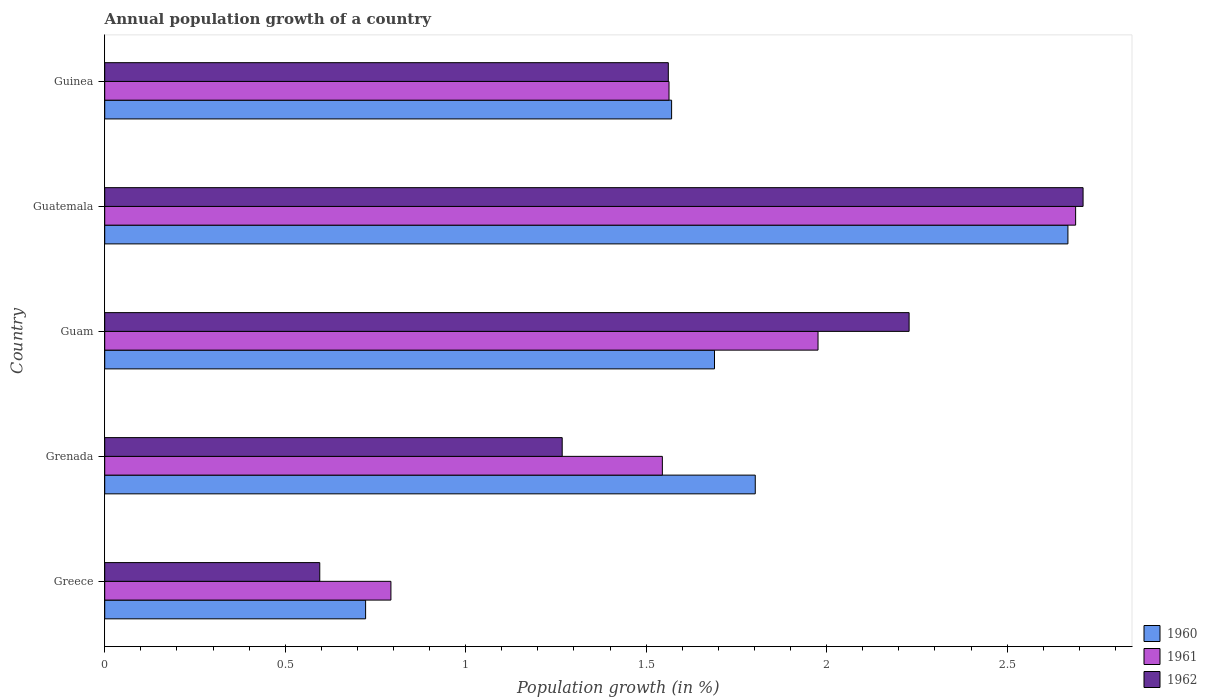Are the number of bars per tick equal to the number of legend labels?
Give a very brief answer. Yes. How many bars are there on the 1st tick from the top?
Provide a short and direct response. 3. How many bars are there on the 3rd tick from the bottom?
Offer a very short reply. 3. What is the label of the 1st group of bars from the top?
Offer a very short reply. Guinea. What is the annual population growth in 1960 in Guatemala?
Offer a very short reply. 2.67. Across all countries, what is the maximum annual population growth in 1962?
Ensure brevity in your answer.  2.71. Across all countries, what is the minimum annual population growth in 1960?
Your answer should be very brief. 0.72. In which country was the annual population growth in 1961 maximum?
Your answer should be compact. Guatemala. In which country was the annual population growth in 1960 minimum?
Give a very brief answer. Greece. What is the total annual population growth in 1961 in the graph?
Offer a terse response. 8.57. What is the difference between the annual population growth in 1961 in Guatemala and that in Guinea?
Provide a short and direct response. 1.13. What is the difference between the annual population growth in 1961 in Guatemala and the annual population growth in 1962 in Greece?
Ensure brevity in your answer.  2.09. What is the average annual population growth in 1961 per country?
Offer a terse response. 1.71. What is the difference between the annual population growth in 1960 and annual population growth in 1962 in Grenada?
Ensure brevity in your answer.  0.53. In how many countries, is the annual population growth in 1961 greater than 1.6 %?
Make the answer very short. 2. What is the ratio of the annual population growth in 1962 in Guam to that in Guatemala?
Offer a very short reply. 0.82. Is the annual population growth in 1962 in Greece less than that in Guatemala?
Give a very brief answer. Yes. Is the difference between the annual population growth in 1960 in Greece and Grenada greater than the difference between the annual population growth in 1962 in Greece and Grenada?
Make the answer very short. No. What is the difference between the highest and the second highest annual population growth in 1961?
Keep it short and to the point. 0.71. What is the difference between the highest and the lowest annual population growth in 1961?
Give a very brief answer. 1.9. What does the 3rd bar from the top in Greece represents?
Your answer should be compact. 1960. What does the 2nd bar from the bottom in Greece represents?
Provide a succinct answer. 1961. Is it the case that in every country, the sum of the annual population growth in 1962 and annual population growth in 1960 is greater than the annual population growth in 1961?
Keep it short and to the point. Yes. How many bars are there?
Give a very brief answer. 15. Are all the bars in the graph horizontal?
Keep it short and to the point. Yes. Does the graph contain grids?
Keep it short and to the point. No. How many legend labels are there?
Your answer should be compact. 3. How are the legend labels stacked?
Ensure brevity in your answer.  Vertical. What is the title of the graph?
Offer a very short reply. Annual population growth of a country. What is the label or title of the X-axis?
Your answer should be compact. Population growth (in %). What is the label or title of the Y-axis?
Offer a very short reply. Country. What is the Population growth (in %) in 1960 in Greece?
Your response must be concise. 0.72. What is the Population growth (in %) in 1961 in Greece?
Ensure brevity in your answer.  0.79. What is the Population growth (in %) of 1962 in Greece?
Make the answer very short. 0.6. What is the Population growth (in %) in 1960 in Grenada?
Provide a short and direct response. 1.8. What is the Population growth (in %) in 1961 in Grenada?
Provide a short and direct response. 1.54. What is the Population growth (in %) in 1962 in Grenada?
Offer a terse response. 1.27. What is the Population growth (in %) in 1960 in Guam?
Offer a terse response. 1.69. What is the Population growth (in %) of 1961 in Guam?
Ensure brevity in your answer.  1.98. What is the Population growth (in %) in 1962 in Guam?
Give a very brief answer. 2.23. What is the Population growth (in %) of 1960 in Guatemala?
Your answer should be very brief. 2.67. What is the Population growth (in %) of 1961 in Guatemala?
Ensure brevity in your answer.  2.69. What is the Population growth (in %) in 1962 in Guatemala?
Give a very brief answer. 2.71. What is the Population growth (in %) of 1960 in Guinea?
Your answer should be compact. 1.57. What is the Population growth (in %) in 1961 in Guinea?
Keep it short and to the point. 1.56. What is the Population growth (in %) of 1962 in Guinea?
Provide a succinct answer. 1.56. Across all countries, what is the maximum Population growth (in %) of 1960?
Keep it short and to the point. 2.67. Across all countries, what is the maximum Population growth (in %) of 1961?
Provide a succinct answer. 2.69. Across all countries, what is the maximum Population growth (in %) of 1962?
Provide a succinct answer. 2.71. Across all countries, what is the minimum Population growth (in %) of 1960?
Offer a terse response. 0.72. Across all countries, what is the minimum Population growth (in %) of 1961?
Your answer should be very brief. 0.79. Across all countries, what is the minimum Population growth (in %) of 1962?
Provide a short and direct response. 0.6. What is the total Population growth (in %) of 1960 in the graph?
Provide a short and direct response. 8.45. What is the total Population growth (in %) in 1961 in the graph?
Provide a short and direct response. 8.57. What is the total Population growth (in %) of 1962 in the graph?
Your response must be concise. 8.36. What is the difference between the Population growth (in %) in 1960 in Greece and that in Grenada?
Your answer should be compact. -1.08. What is the difference between the Population growth (in %) in 1961 in Greece and that in Grenada?
Your answer should be very brief. -0.75. What is the difference between the Population growth (in %) in 1962 in Greece and that in Grenada?
Offer a terse response. -0.67. What is the difference between the Population growth (in %) of 1960 in Greece and that in Guam?
Give a very brief answer. -0.97. What is the difference between the Population growth (in %) of 1961 in Greece and that in Guam?
Provide a short and direct response. -1.18. What is the difference between the Population growth (in %) in 1962 in Greece and that in Guam?
Your answer should be compact. -1.63. What is the difference between the Population growth (in %) of 1960 in Greece and that in Guatemala?
Give a very brief answer. -1.95. What is the difference between the Population growth (in %) in 1961 in Greece and that in Guatemala?
Give a very brief answer. -1.9. What is the difference between the Population growth (in %) of 1962 in Greece and that in Guatemala?
Your response must be concise. -2.11. What is the difference between the Population growth (in %) of 1960 in Greece and that in Guinea?
Provide a succinct answer. -0.85. What is the difference between the Population growth (in %) of 1961 in Greece and that in Guinea?
Keep it short and to the point. -0.77. What is the difference between the Population growth (in %) of 1962 in Greece and that in Guinea?
Offer a terse response. -0.97. What is the difference between the Population growth (in %) in 1960 in Grenada and that in Guam?
Offer a terse response. 0.11. What is the difference between the Population growth (in %) of 1961 in Grenada and that in Guam?
Provide a succinct answer. -0.43. What is the difference between the Population growth (in %) in 1962 in Grenada and that in Guam?
Your answer should be compact. -0.96. What is the difference between the Population growth (in %) of 1960 in Grenada and that in Guatemala?
Give a very brief answer. -0.87. What is the difference between the Population growth (in %) in 1961 in Grenada and that in Guatemala?
Provide a short and direct response. -1.14. What is the difference between the Population growth (in %) of 1962 in Grenada and that in Guatemala?
Offer a very short reply. -1.44. What is the difference between the Population growth (in %) in 1960 in Grenada and that in Guinea?
Your answer should be compact. 0.23. What is the difference between the Population growth (in %) of 1961 in Grenada and that in Guinea?
Offer a terse response. -0.02. What is the difference between the Population growth (in %) in 1962 in Grenada and that in Guinea?
Ensure brevity in your answer.  -0.29. What is the difference between the Population growth (in %) in 1960 in Guam and that in Guatemala?
Give a very brief answer. -0.98. What is the difference between the Population growth (in %) in 1961 in Guam and that in Guatemala?
Provide a short and direct response. -0.71. What is the difference between the Population growth (in %) in 1962 in Guam and that in Guatemala?
Ensure brevity in your answer.  -0.48. What is the difference between the Population growth (in %) of 1960 in Guam and that in Guinea?
Provide a short and direct response. 0.12. What is the difference between the Population growth (in %) of 1961 in Guam and that in Guinea?
Your response must be concise. 0.41. What is the difference between the Population growth (in %) of 1962 in Guam and that in Guinea?
Offer a terse response. 0.67. What is the difference between the Population growth (in %) of 1960 in Guatemala and that in Guinea?
Your answer should be compact. 1.1. What is the difference between the Population growth (in %) in 1961 in Guatemala and that in Guinea?
Your answer should be very brief. 1.13. What is the difference between the Population growth (in %) in 1962 in Guatemala and that in Guinea?
Provide a short and direct response. 1.15. What is the difference between the Population growth (in %) of 1960 in Greece and the Population growth (in %) of 1961 in Grenada?
Offer a very short reply. -0.82. What is the difference between the Population growth (in %) in 1960 in Greece and the Population growth (in %) in 1962 in Grenada?
Your answer should be compact. -0.54. What is the difference between the Population growth (in %) of 1961 in Greece and the Population growth (in %) of 1962 in Grenada?
Provide a short and direct response. -0.47. What is the difference between the Population growth (in %) in 1960 in Greece and the Population growth (in %) in 1961 in Guam?
Provide a short and direct response. -1.25. What is the difference between the Population growth (in %) of 1960 in Greece and the Population growth (in %) of 1962 in Guam?
Keep it short and to the point. -1.51. What is the difference between the Population growth (in %) in 1961 in Greece and the Population growth (in %) in 1962 in Guam?
Keep it short and to the point. -1.44. What is the difference between the Population growth (in %) of 1960 in Greece and the Population growth (in %) of 1961 in Guatemala?
Offer a very short reply. -1.97. What is the difference between the Population growth (in %) of 1960 in Greece and the Population growth (in %) of 1962 in Guatemala?
Offer a very short reply. -1.99. What is the difference between the Population growth (in %) in 1961 in Greece and the Population growth (in %) in 1962 in Guatemala?
Provide a short and direct response. -1.92. What is the difference between the Population growth (in %) in 1960 in Greece and the Population growth (in %) in 1961 in Guinea?
Your answer should be compact. -0.84. What is the difference between the Population growth (in %) of 1960 in Greece and the Population growth (in %) of 1962 in Guinea?
Offer a terse response. -0.84. What is the difference between the Population growth (in %) of 1961 in Greece and the Population growth (in %) of 1962 in Guinea?
Provide a short and direct response. -0.77. What is the difference between the Population growth (in %) in 1960 in Grenada and the Population growth (in %) in 1961 in Guam?
Your answer should be compact. -0.17. What is the difference between the Population growth (in %) of 1960 in Grenada and the Population growth (in %) of 1962 in Guam?
Provide a short and direct response. -0.43. What is the difference between the Population growth (in %) in 1961 in Grenada and the Population growth (in %) in 1962 in Guam?
Make the answer very short. -0.68. What is the difference between the Population growth (in %) in 1960 in Grenada and the Population growth (in %) in 1961 in Guatemala?
Your answer should be very brief. -0.89. What is the difference between the Population growth (in %) of 1960 in Grenada and the Population growth (in %) of 1962 in Guatemala?
Ensure brevity in your answer.  -0.91. What is the difference between the Population growth (in %) of 1961 in Grenada and the Population growth (in %) of 1962 in Guatemala?
Provide a succinct answer. -1.17. What is the difference between the Population growth (in %) in 1960 in Grenada and the Population growth (in %) in 1961 in Guinea?
Make the answer very short. 0.24. What is the difference between the Population growth (in %) in 1960 in Grenada and the Population growth (in %) in 1962 in Guinea?
Provide a succinct answer. 0.24. What is the difference between the Population growth (in %) in 1961 in Grenada and the Population growth (in %) in 1962 in Guinea?
Offer a very short reply. -0.02. What is the difference between the Population growth (in %) in 1960 in Guam and the Population growth (in %) in 1961 in Guatemala?
Offer a very short reply. -1. What is the difference between the Population growth (in %) in 1960 in Guam and the Population growth (in %) in 1962 in Guatemala?
Offer a very short reply. -1.02. What is the difference between the Population growth (in %) in 1961 in Guam and the Population growth (in %) in 1962 in Guatemala?
Your answer should be compact. -0.73. What is the difference between the Population growth (in %) of 1960 in Guam and the Population growth (in %) of 1961 in Guinea?
Your response must be concise. 0.13. What is the difference between the Population growth (in %) of 1960 in Guam and the Population growth (in %) of 1962 in Guinea?
Offer a terse response. 0.13. What is the difference between the Population growth (in %) in 1961 in Guam and the Population growth (in %) in 1962 in Guinea?
Offer a terse response. 0.41. What is the difference between the Population growth (in %) in 1960 in Guatemala and the Population growth (in %) in 1961 in Guinea?
Keep it short and to the point. 1.11. What is the difference between the Population growth (in %) of 1960 in Guatemala and the Population growth (in %) of 1962 in Guinea?
Make the answer very short. 1.11. What is the difference between the Population growth (in %) of 1961 in Guatemala and the Population growth (in %) of 1962 in Guinea?
Offer a very short reply. 1.13. What is the average Population growth (in %) in 1960 per country?
Give a very brief answer. 1.69. What is the average Population growth (in %) of 1961 per country?
Provide a succinct answer. 1.71. What is the average Population growth (in %) in 1962 per country?
Give a very brief answer. 1.67. What is the difference between the Population growth (in %) of 1960 and Population growth (in %) of 1961 in Greece?
Offer a very short reply. -0.07. What is the difference between the Population growth (in %) in 1960 and Population growth (in %) in 1962 in Greece?
Your response must be concise. 0.13. What is the difference between the Population growth (in %) in 1961 and Population growth (in %) in 1962 in Greece?
Your response must be concise. 0.2. What is the difference between the Population growth (in %) of 1960 and Population growth (in %) of 1961 in Grenada?
Your response must be concise. 0.26. What is the difference between the Population growth (in %) of 1960 and Population growth (in %) of 1962 in Grenada?
Give a very brief answer. 0.53. What is the difference between the Population growth (in %) of 1961 and Population growth (in %) of 1962 in Grenada?
Offer a very short reply. 0.28. What is the difference between the Population growth (in %) of 1960 and Population growth (in %) of 1961 in Guam?
Offer a terse response. -0.29. What is the difference between the Population growth (in %) of 1960 and Population growth (in %) of 1962 in Guam?
Give a very brief answer. -0.54. What is the difference between the Population growth (in %) in 1961 and Population growth (in %) in 1962 in Guam?
Your answer should be compact. -0.25. What is the difference between the Population growth (in %) in 1960 and Population growth (in %) in 1961 in Guatemala?
Offer a very short reply. -0.02. What is the difference between the Population growth (in %) in 1960 and Population growth (in %) in 1962 in Guatemala?
Your answer should be very brief. -0.04. What is the difference between the Population growth (in %) of 1961 and Population growth (in %) of 1962 in Guatemala?
Your response must be concise. -0.02. What is the difference between the Population growth (in %) in 1960 and Population growth (in %) in 1961 in Guinea?
Give a very brief answer. 0.01. What is the difference between the Population growth (in %) of 1960 and Population growth (in %) of 1962 in Guinea?
Keep it short and to the point. 0.01. What is the difference between the Population growth (in %) in 1961 and Population growth (in %) in 1962 in Guinea?
Your answer should be very brief. 0. What is the ratio of the Population growth (in %) in 1960 in Greece to that in Grenada?
Provide a succinct answer. 0.4. What is the ratio of the Population growth (in %) of 1961 in Greece to that in Grenada?
Your answer should be very brief. 0.51. What is the ratio of the Population growth (in %) in 1962 in Greece to that in Grenada?
Provide a short and direct response. 0.47. What is the ratio of the Population growth (in %) of 1960 in Greece to that in Guam?
Make the answer very short. 0.43. What is the ratio of the Population growth (in %) of 1961 in Greece to that in Guam?
Give a very brief answer. 0.4. What is the ratio of the Population growth (in %) in 1962 in Greece to that in Guam?
Keep it short and to the point. 0.27. What is the ratio of the Population growth (in %) in 1960 in Greece to that in Guatemala?
Your answer should be very brief. 0.27. What is the ratio of the Population growth (in %) of 1961 in Greece to that in Guatemala?
Provide a succinct answer. 0.29. What is the ratio of the Population growth (in %) in 1962 in Greece to that in Guatemala?
Your answer should be compact. 0.22. What is the ratio of the Population growth (in %) in 1960 in Greece to that in Guinea?
Your answer should be very brief. 0.46. What is the ratio of the Population growth (in %) in 1961 in Greece to that in Guinea?
Your response must be concise. 0.51. What is the ratio of the Population growth (in %) of 1962 in Greece to that in Guinea?
Offer a very short reply. 0.38. What is the ratio of the Population growth (in %) of 1960 in Grenada to that in Guam?
Ensure brevity in your answer.  1.07. What is the ratio of the Population growth (in %) in 1961 in Grenada to that in Guam?
Offer a very short reply. 0.78. What is the ratio of the Population growth (in %) in 1962 in Grenada to that in Guam?
Your answer should be compact. 0.57. What is the ratio of the Population growth (in %) in 1960 in Grenada to that in Guatemala?
Your response must be concise. 0.68. What is the ratio of the Population growth (in %) in 1961 in Grenada to that in Guatemala?
Your response must be concise. 0.57. What is the ratio of the Population growth (in %) of 1962 in Grenada to that in Guatemala?
Provide a short and direct response. 0.47. What is the ratio of the Population growth (in %) of 1960 in Grenada to that in Guinea?
Provide a succinct answer. 1.15. What is the ratio of the Population growth (in %) of 1962 in Grenada to that in Guinea?
Offer a very short reply. 0.81. What is the ratio of the Population growth (in %) of 1960 in Guam to that in Guatemala?
Keep it short and to the point. 0.63. What is the ratio of the Population growth (in %) of 1961 in Guam to that in Guatemala?
Give a very brief answer. 0.73. What is the ratio of the Population growth (in %) of 1962 in Guam to that in Guatemala?
Ensure brevity in your answer.  0.82. What is the ratio of the Population growth (in %) in 1960 in Guam to that in Guinea?
Your answer should be very brief. 1.08. What is the ratio of the Population growth (in %) of 1961 in Guam to that in Guinea?
Offer a very short reply. 1.26. What is the ratio of the Population growth (in %) of 1962 in Guam to that in Guinea?
Your response must be concise. 1.43. What is the ratio of the Population growth (in %) of 1960 in Guatemala to that in Guinea?
Keep it short and to the point. 1.7. What is the ratio of the Population growth (in %) of 1961 in Guatemala to that in Guinea?
Offer a terse response. 1.72. What is the ratio of the Population growth (in %) in 1962 in Guatemala to that in Guinea?
Make the answer very short. 1.74. What is the difference between the highest and the second highest Population growth (in %) of 1960?
Ensure brevity in your answer.  0.87. What is the difference between the highest and the second highest Population growth (in %) in 1961?
Give a very brief answer. 0.71. What is the difference between the highest and the second highest Population growth (in %) in 1962?
Your response must be concise. 0.48. What is the difference between the highest and the lowest Population growth (in %) in 1960?
Provide a succinct answer. 1.95. What is the difference between the highest and the lowest Population growth (in %) of 1961?
Your response must be concise. 1.9. What is the difference between the highest and the lowest Population growth (in %) of 1962?
Make the answer very short. 2.11. 